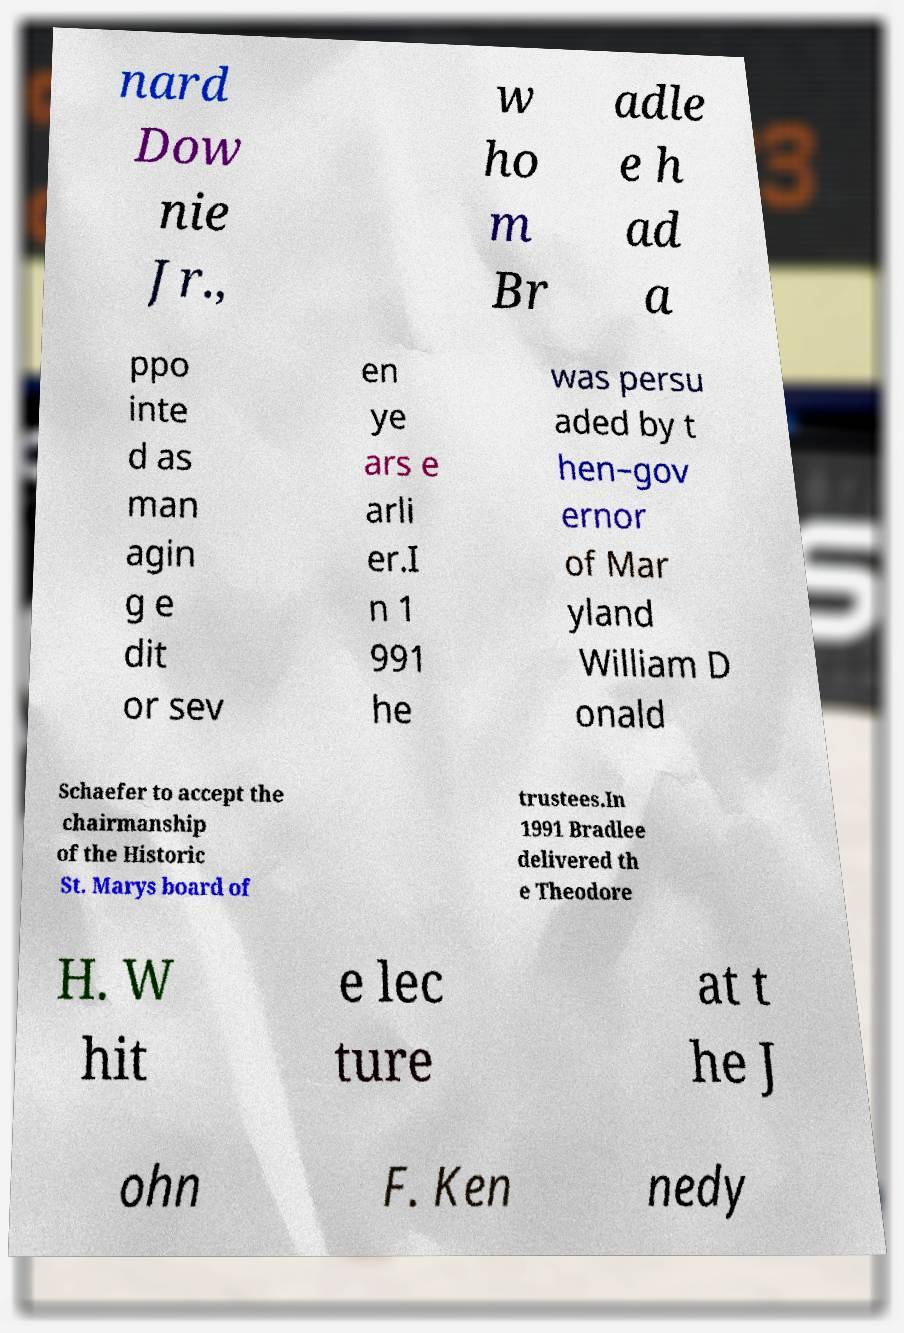Could you assist in decoding the text presented in this image and type it out clearly? nard Dow nie Jr., w ho m Br adle e h ad a ppo inte d as man agin g e dit or sev en ye ars e arli er.I n 1 991 he was persu aded by t hen–gov ernor of Mar yland William D onald Schaefer to accept the chairmanship of the Historic St. Marys board of trustees.In 1991 Bradlee delivered th e Theodore H. W hit e lec ture at t he J ohn F. Ken nedy 